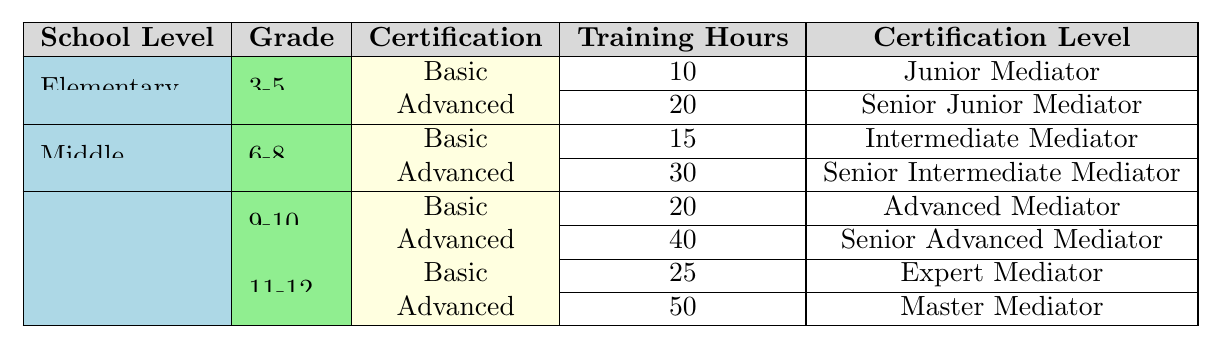What are the training hours required for the Basic Certification in Elementary School for Grades 3-5? The table indicates that the Basic Certification for Grades 3-5 in Elementary School requires 10 training hours.
Answer: 10 How many skills are covered in the Advanced Certification for Middle School? The Advanced Certification for Middle School (Grades 6-8) covers 3 skills: Group Mediation, Restorative Justice Practices, and Bullying Prevention.
Answer: 3 Is the training level for the Advanced Certification in High School (Grades 9-10) higher than the training level for the Basic Certification in the same grade? The Advanced Certification requires 40 training hours, whereas the Basic Certification requires 20 training hours, indicating that the Advanced Certification has a higher level of training.
Answer: Yes What is the total training hours for both Basic and Advanced Certifications combined in High School (Grades 11-12)? Basic Certification requires 25 hours while Advanced Certification requires 50 hours. Adding these two gives 25 + 50 = 75 training hours total for Grades 11-12 in High School.
Answer: 75 Which school level and grade have the highest total training hours for certifications? The High School (Grades 11-12) Advanced Certification requires the most hours (50) while the Basic Certification requires 25 hours, making a total of 75 hours. This is higher than any other configuration in the table.
Answer: High School (Grades 11-12) What is the difference in training hours between the Advanced Certification in Middle School and the Basic Certification in High School (Grades 9-10)? The Advanced Certification in Middle School requires 30 hours, and the Basic Certification in High School (Grades 9-10) requires 20 hours. The difference is 30 - 20 = 10 hours.
Answer: 10 Which specific skills are covered in the Basic Certification of High School Grades 11-12? According to the table, the skills covered are Complex Conflict Resolution, Mediation Program Management, and Mentoring Junior Mediators.
Answer: 3 skills Is the certification level for Advanced Certification in Elementary School higher than in Middle School? In Elementary School, the Advanced Certification level is Senior Junior Mediator, while in Middle School, it is Senior Intermediate Mediator. Since "Senior Intermediate Mediator" is a higher rank than "Senior Junior Mediator," the statement is true.
Answer: No What is the average number of training hours required for Basic Certifications across all school levels? The Basic Certification in Elementary School is 10 hours, in Middle School is 15 hours, and in High School (Grades 9-10) is 20 hours, and in High School (Grades 11-12) is 25 hours. The total is 10 + 15 + 20 + 25 = 70 hours for 4 certifications, thus 70 / 4 = 17.5 hours average.
Answer: 17.5 How many total certification levels are listed for the entire table? The table lists a total of 8 certification levels: Junior Mediator, Senior Junior Mediator, Intermediate Mediator, Senior Intermediate Mediator, Advanced Mediator, Senior Advanced Mediator, Expert Mediator, Master Mediator.
Answer: 8 